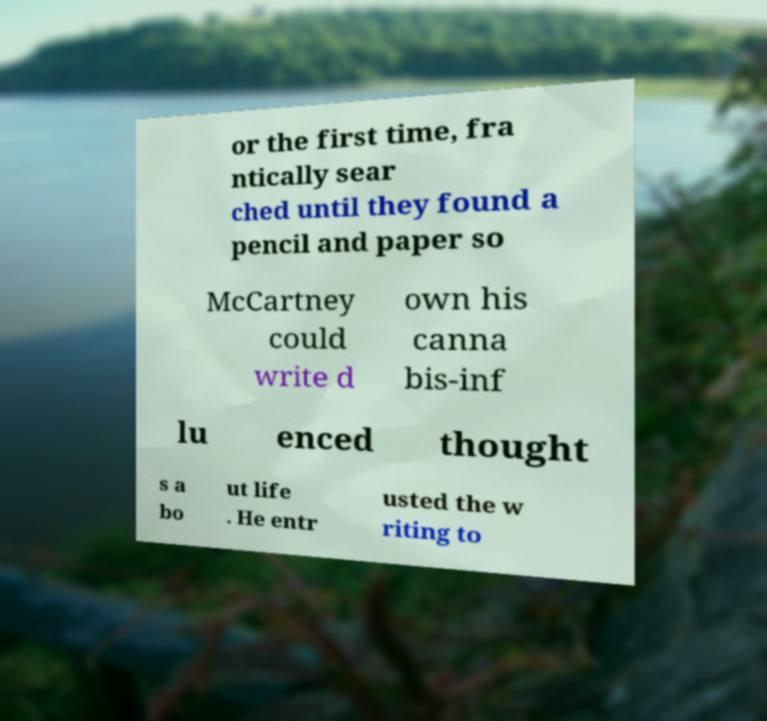Can you read and provide the text displayed in the image?This photo seems to have some interesting text. Can you extract and type it out for me? or the first time, fra ntically sear ched until they found a pencil and paper so McCartney could write d own his canna bis-inf lu enced thought s a bo ut life . He entr usted the w riting to 